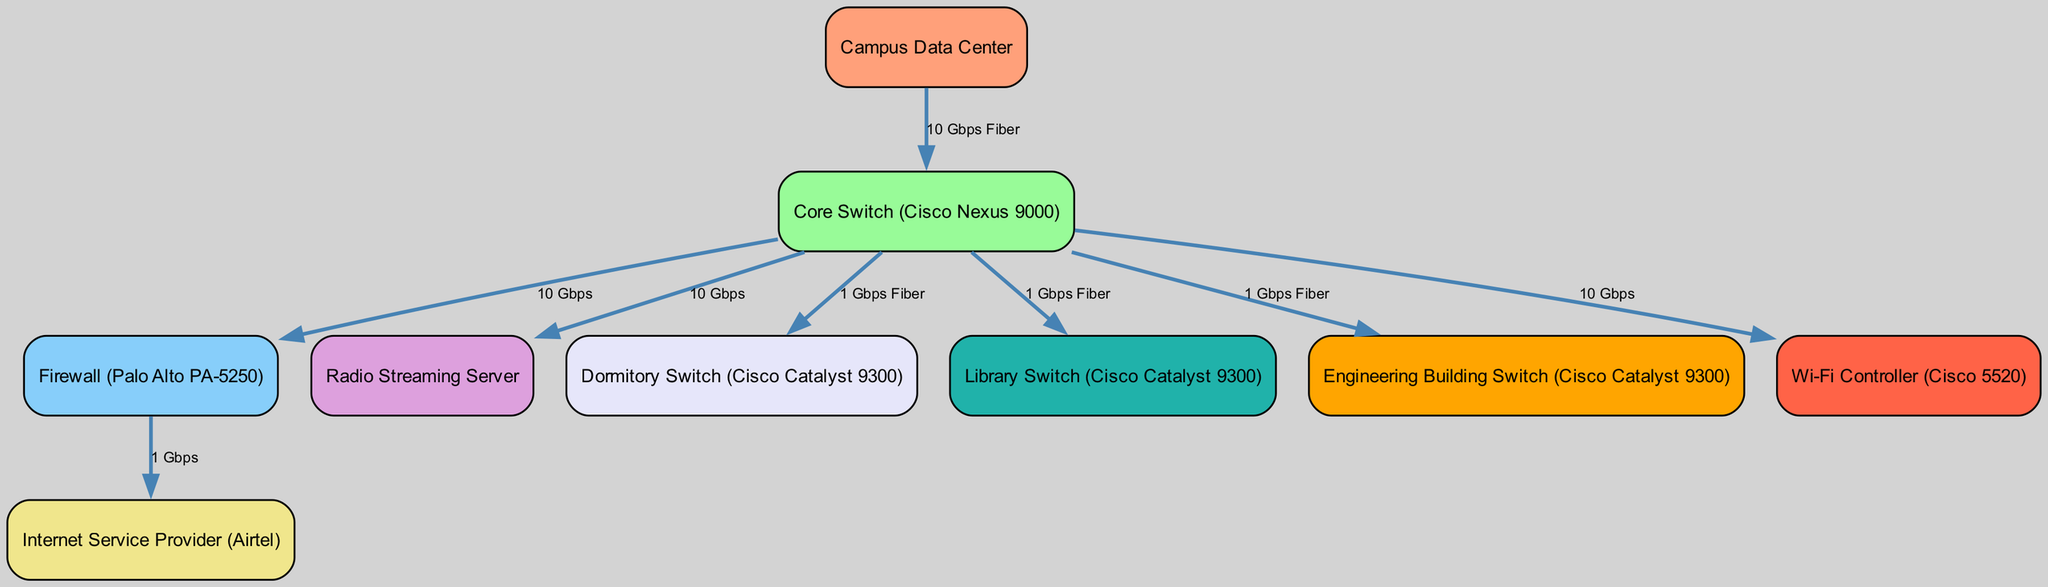What is the label of the node connected to the core switch that handles streaming? The core switch connects to the radio streaming server, which is responsible for handling streaming services on the campus network.
Answer: Radio Streaming Server How many switches are present in the diagram? The diagram features four switches: the dormitory switch, library switch, engineering building switch, and core switch, plus the core switch itself, making a total of five switches.
Answer: Five What type of connection does the firewall have with the ISP? The connection from the firewall to the Internet Service Provider is labeled as 1 Gbps, indicating the bandwidth of the link.
Answer: 1 Gbps What is the connection type between the core switch and the dormitory switch? The connection from the core switch to the dormitory switch is indicated as 1 Gbps Fiber, specifying both the bandwidth and the type of connection.
Answer: 1 Gbps Fiber Which switch is directly connected to the Wi-Fi controller? The diagram shows that the Wi-Fi controller is directly connected to the core switch, indicating that the core switch handles Wi-Fi traffic.
Answer: Core Switch What is the main function of the firewall in the network? The firewall's main function is to serve as a security barrier controlling traffic between the internal network and the ISP.
Answer: Security Barrier How many nodes are connected to the core switch? The core switch has five nodes: the radio streaming server, firewall, dormitory switch, library switch, and engineering building switch connected to it.
Answer: Five What is the data transfer rate from the core switch to the streaming server? The data transfer rate from the core switch to the radio streaming server is specified as 10 Gbps, representing the high bandwidth connection used for streaming media.
Answer: 10 Gbps Which node represents the entry point for external internet connectivity in the diagram? The ISP node represents the entry point for external internet connectivity, as it connects the internal network to the internet.
Answer: Internet Service Provider 